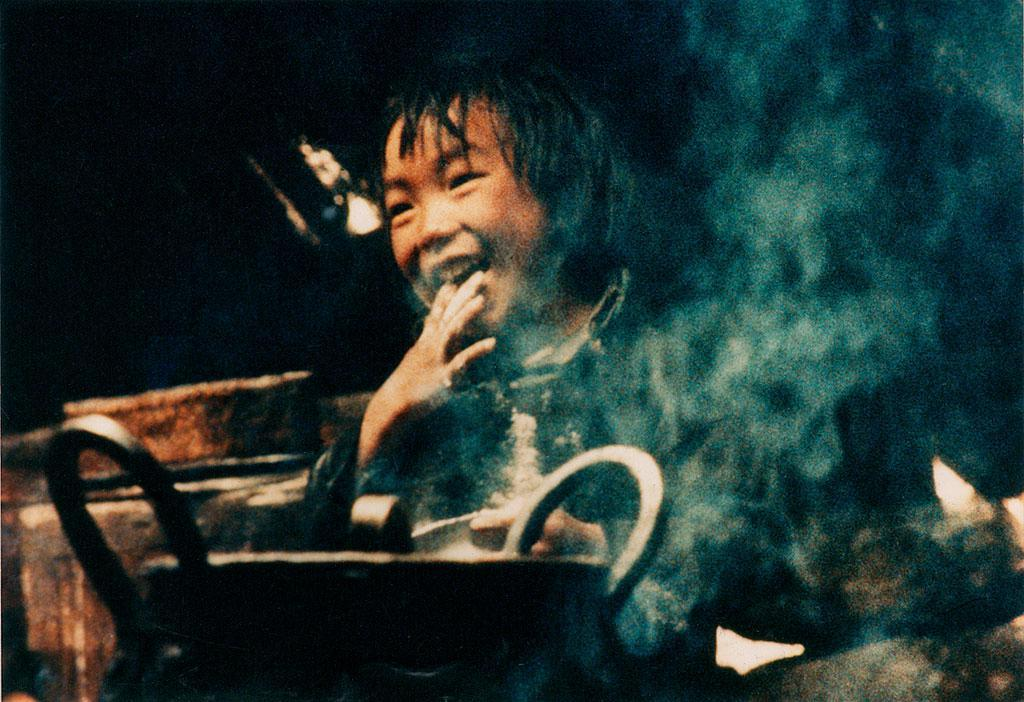What object can be seen in the image that is used for eating or cooking? There is a utensil present in the image. What can be observed in the image that indicates a possible activity or event? There is smoke visible in the image. Who is in the image? A child is in the image. What is the child's expression in the image? The child is smiling. What can be said about the lighting or time of day in the image? The background of the image is dark. What is the manager's role in the image? There is no manager present in the image. What is the purpose of the cannon in the image? There is no cannon present in the image. 